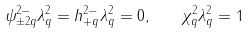<formula> <loc_0><loc_0><loc_500><loc_500>\psi ^ { 2 - } _ { \pm 2 q } \lambda ^ { 2 } _ { q } = h ^ { 2 - } _ { + q } \lambda ^ { 2 } _ { q } = 0 , \quad \chi ^ { 2 } _ { q } \lambda ^ { 2 } _ { q } = 1</formula> 